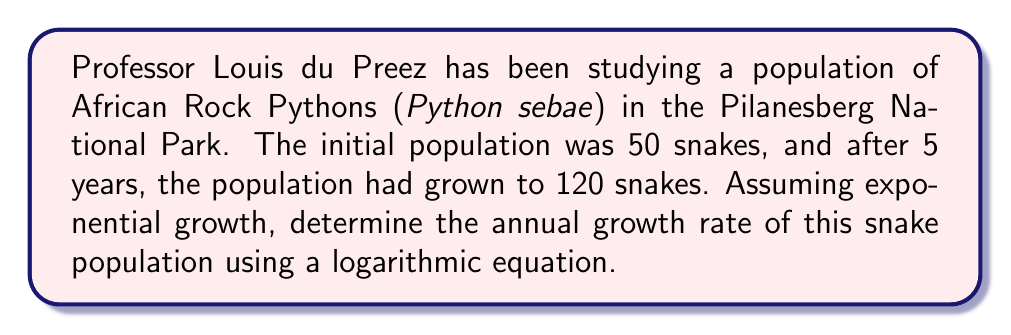Can you solve this math problem? Let's approach this step-by-step using the exponential growth formula and logarithms:

1) The exponential growth formula is:
   $$A = P(1+r)^t$$
   Where:
   $A$ = Final amount
   $P$ = Initial amount
   $r$ = Growth rate (as a decimal)
   $t$ = Time period

2) We know:
   $P = 50$ (initial population)
   $A = 120$ (final population)
   $t = 5$ years

3) Let's substitute these into our equation:
   $$120 = 50(1+r)^5$$

4) Divide both sides by 50:
   $$\frac{120}{50} = (1+r)^5$$
   $$2.4 = (1+r)^5$$

5) Now, we can use logarithms to solve for $r$. Let's use the natural log (ln):
   $$\ln(2.4) = \ln((1+r)^5)$$

6) Using the logarithm property $\ln(x^n) = n\ln(x)$:
   $$\ln(2.4) = 5\ln(1+r)$$

7) Divide both sides by 5:
   $$\frac{\ln(2.4)}{5} = \ln(1+r)$$

8) Now we can use $e^x$ on both sides to remove the ln:
   $$e^{\frac{\ln(2.4)}{5}} = e^{\ln(1+r)} = 1+r$$

9) Subtract 1 from both sides:
   $$e^{\frac{\ln(2.4)}{5}} - 1 = r$$

10) Calculate the value:
    $$r \approx 0.1914 \text{ or } 19.14\%$$
Answer: The annual growth rate of the African Rock Python population is approximately 19.14%. 